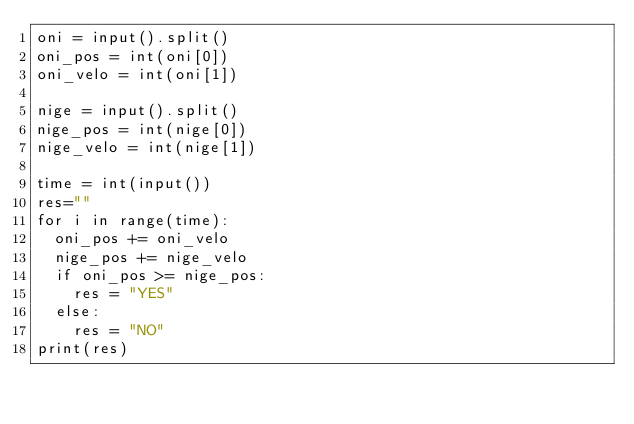<code> <loc_0><loc_0><loc_500><loc_500><_Python_>oni = input().split()
oni_pos = int(oni[0])
oni_velo = int(oni[1])

nige = input().split()
nige_pos = int(nige[0])
nige_velo = int(nige[1])

time = int(input())
res=""
for i in range(time):
  oni_pos += oni_velo
  nige_pos += nige_velo
  if oni_pos >= nige_pos:
    res = "YES"
  else:
  	res = "NO"
print(res)</code> 